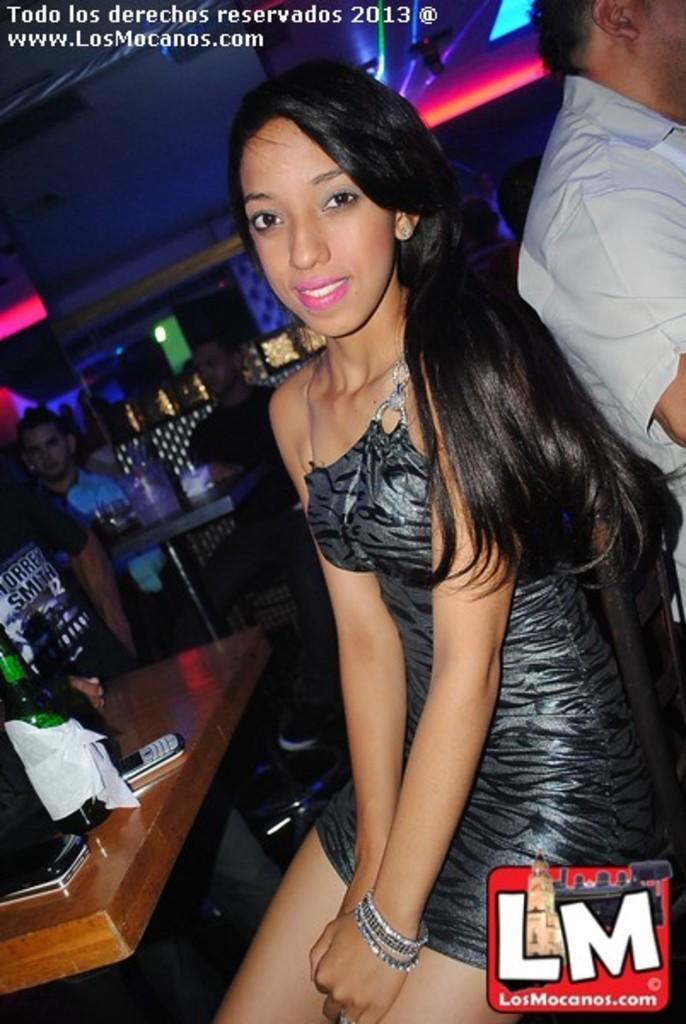Could you give a brief overview of what you see in this image? In this image I can see a person sitting and posing. There are few other people, there are some objects on the tables, also there are lights. And at the top and bottom of the image there are two watermarks. 